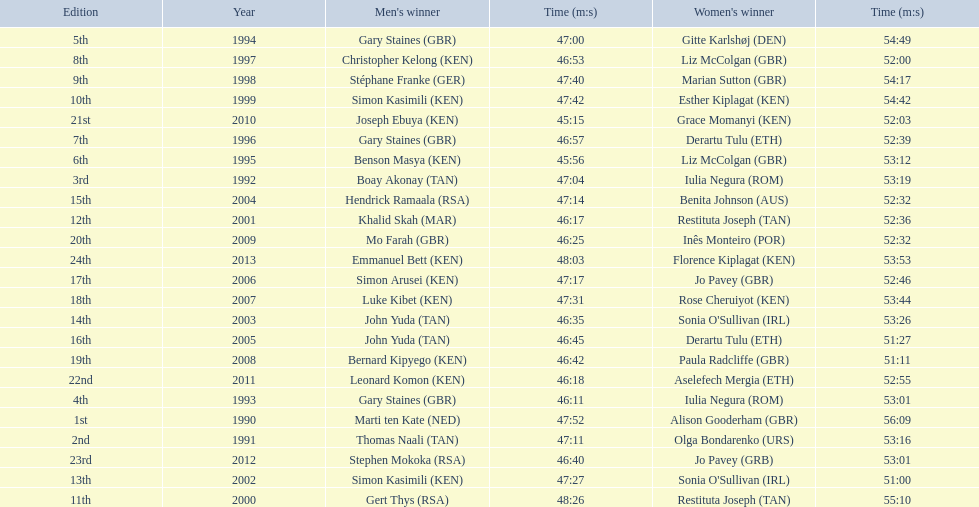What years were the races held? 1990, 1991, 1992, 1993, 1994, 1995, 1996, 1997, 1998, 1999, 2000, 2001, 2002, 2003, 2004, 2005, 2006, 2007, 2008, 2009, 2010, 2011, 2012, 2013. Who was the woman's winner of the 2003 race? Sonia O'Sullivan (IRL). What was her time? 53:26. 